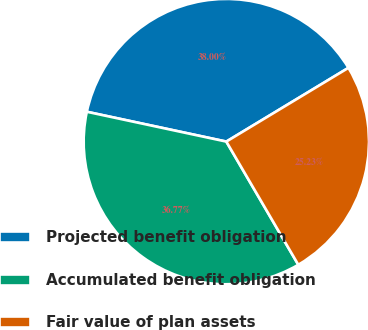Convert chart to OTSL. <chart><loc_0><loc_0><loc_500><loc_500><pie_chart><fcel>Projected benefit obligation<fcel>Accumulated benefit obligation<fcel>Fair value of plan assets<nl><fcel>38.0%<fcel>36.77%<fcel>25.23%<nl></chart> 